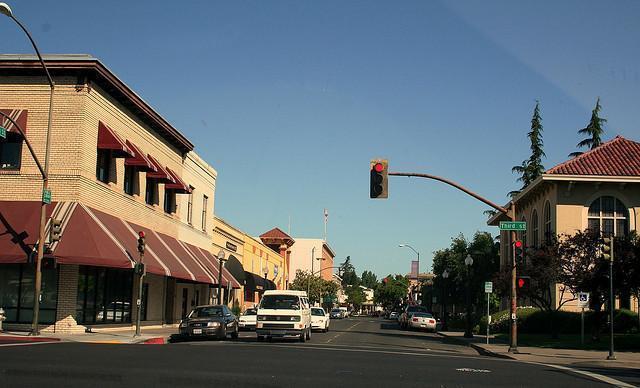From which material is the roofing most visible here sourced?
Choose the right answer from the provided options to respond to the question.
Options: Clay, tar, concrete, wood. Clay. 